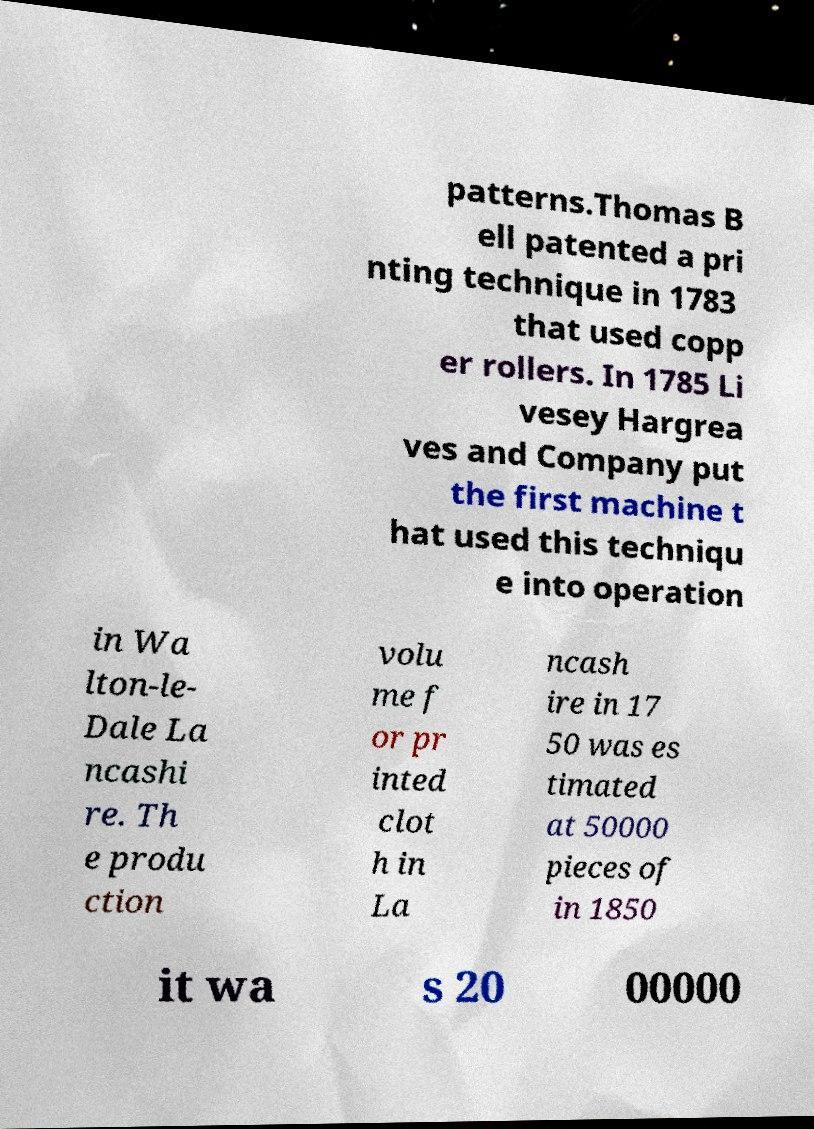Please read and relay the text visible in this image. What does it say? patterns.Thomas B ell patented a pri nting technique in 1783 that used copp er rollers. In 1785 Li vesey Hargrea ves and Company put the first machine t hat used this techniqu e into operation in Wa lton-le- Dale La ncashi re. Th e produ ction volu me f or pr inted clot h in La ncash ire in 17 50 was es timated at 50000 pieces of in 1850 it wa s 20 00000 